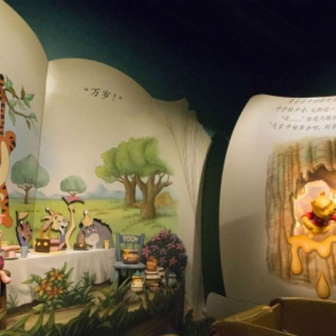Describe the following image. The image depicts a delightful scene from the beloved children's story, Winnie the Pooh, portrayed on a creatively curved wall in a children's play area. The mural is vibrant and colorful, executed in a classic cartoon style. Centered around Winnie the Pooh, who is reaching towards a honey pot on a picnic table, the scene includes several beloved characters in their recognizable hues. To Pooh's right, Tigger is captured mid-leap, showcasing his characteristic energy with his orange and black stripes. Piglet stands timidly to Pooh's left, while Eeyore, the somber gray donkey, stands on the far right. The characters are all positioned around a grand tree that stretches upwards with lush green foliage, set against a serene blue sky. Adding a multicultural dimension, the mural features text in both Japanese and English, enriching this enchanting depiction of a classic tale. 